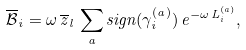<formula> <loc_0><loc_0><loc_500><loc_500>\overline { \mathcal { B } } _ { i } = \omega \, \overline { z } _ { l } \, \sum _ { a } s i g n ( \gamma _ { i } ^ { ( a ) } ) \, e ^ { - \omega \, L _ { i } ^ { ( a ) } } ,</formula> 